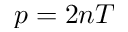<formula> <loc_0><loc_0><loc_500><loc_500>p = 2 n T</formula> 